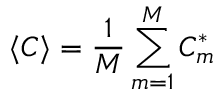Convert formula to latex. <formula><loc_0><loc_0><loc_500><loc_500>\langle C \rangle = \frac { 1 } { M } \sum _ { m = 1 } ^ { M } C _ { m } ^ { * }</formula> 